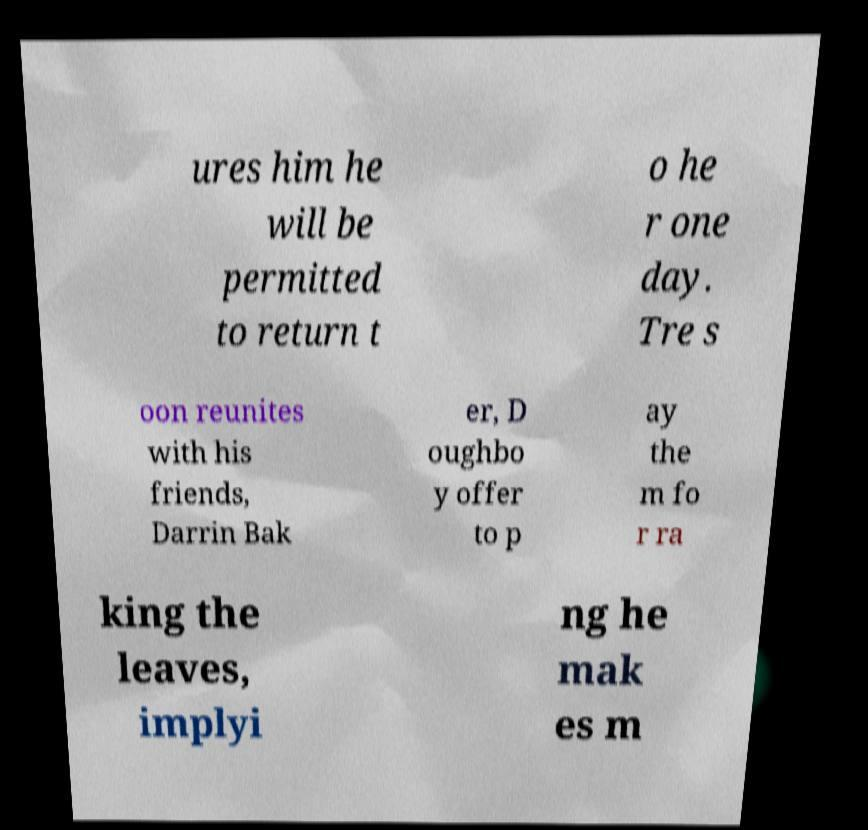I need the written content from this picture converted into text. Can you do that? ures him he will be permitted to return t o he r one day. Tre s oon reunites with his friends, Darrin Bak er, D oughbo y offer to p ay the m fo r ra king the leaves, implyi ng he mak es m 